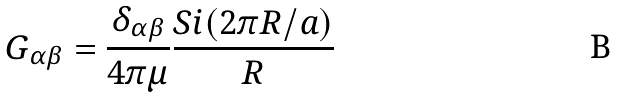Convert formula to latex. <formula><loc_0><loc_0><loc_500><loc_500>G _ { \alpha \beta } = \frac { \delta _ { \alpha \beta } } { 4 \pi \mu } \frac { S i ( 2 \pi R / a ) } { R }</formula> 